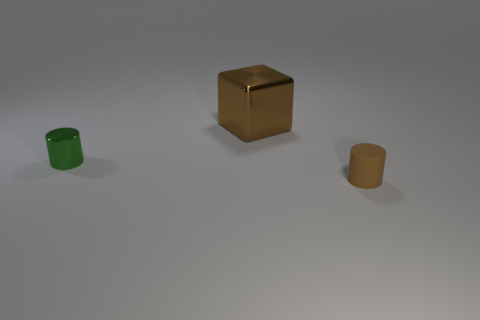Add 1 metallic things. How many objects exist? 4 Subtract all blocks. How many objects are left? 2 Subtract 0 blue cubes. How many objects are left? 3 Subtract all tiny red cubes. Subtract all shiny blocks. How many objects are left? 2 Add 1 small brown rubber things. How many small brown rubber things are left? 2 Add 1 tiny cyan matte balls. How many tiny cyan matte balls exist? 1 